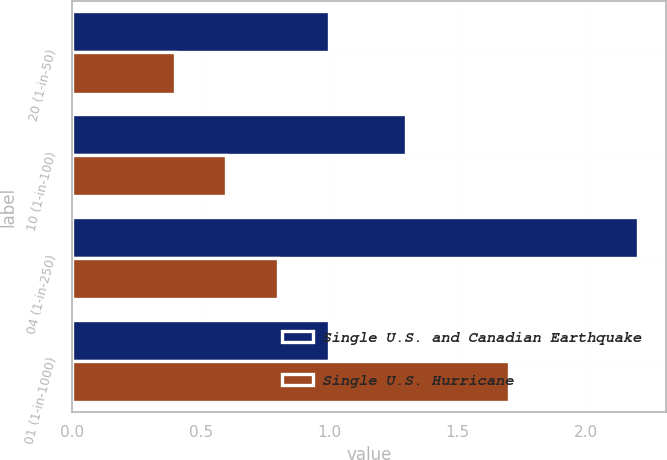Convert chart to OTSL. <chart><loc_0><loc_0><loc_500><loc_500><stacked_bar_chart><ecel><fcel>20 (1-in-50)<fcel>10 (1-in-100)<fcel>04 (1-in-250)<fcel>01 (1-in-1000)<nl><fcel>Single U.S. and Canadian Earthquake<fcel>1<fcel>1.3<fcel>2.2<fcel>1<nl><fcel>Single U.S. Hurricane<fcel>0.4<fcel>0.6<fcel>0.8<fcel>1.7<nl></chart> 